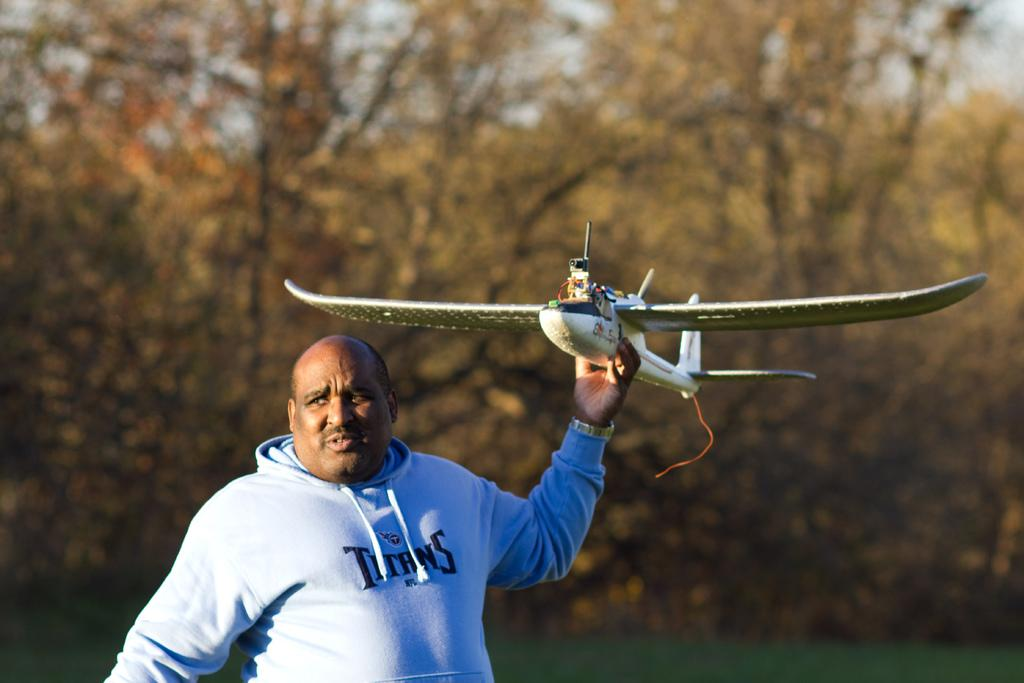<image>
Write a terse but informative summary of the picture. A Titans fan is holding a model airplane. 